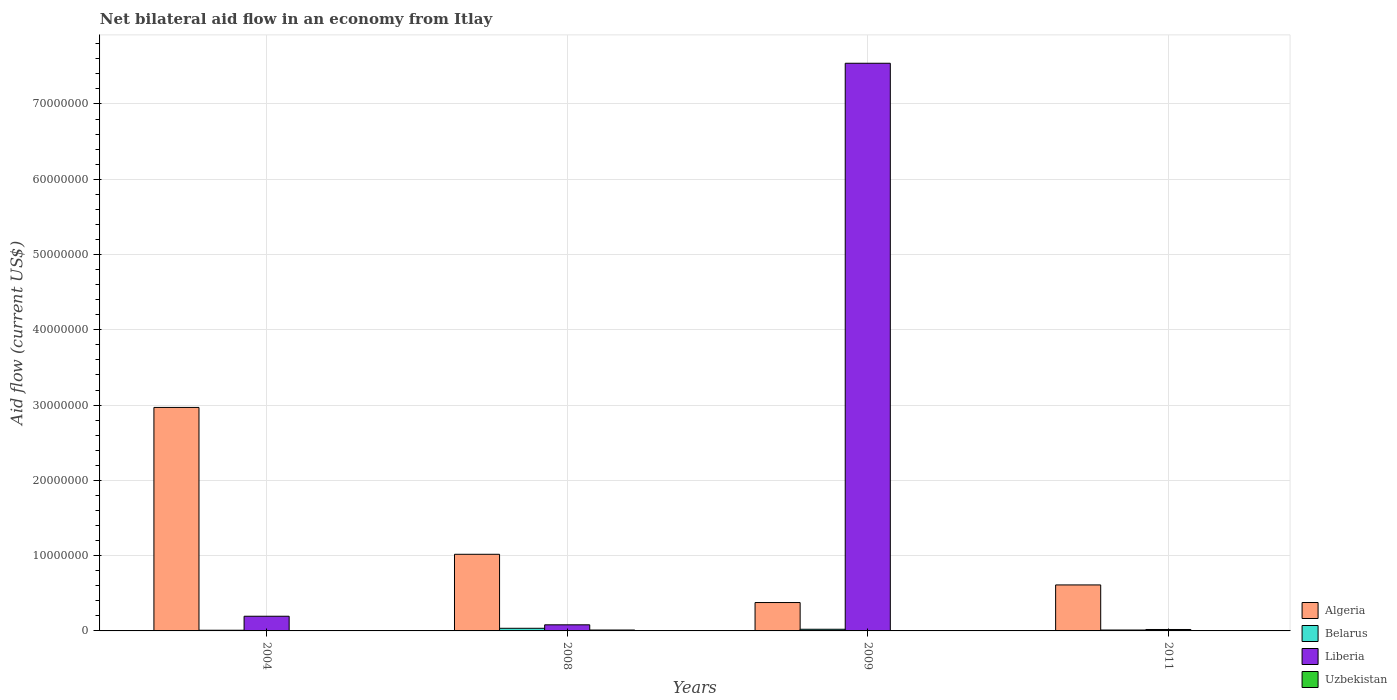How many different coloured bars are there?
Your response must be concise. 4. Are the number of bars per tick equal to the number of legend labels?
Ensure brevity in your answer.  Yes. How many bars are there on the 4th tick from the left?
Offer a very short reply. 4. How many bars are there on the 3rd tick from the right?
Offer a very short reply. 4. What is the label of the 1st group of bars from the left?
Your answer should be very brief. 2004. In how many cases, is the number of bars for a given year not equal to the number of legend labels?
Your response must be concise. 0. What is the net bilateral aid flow in Liberia in 2004?
Provide a short and direct response. 1.95e+06. Across all years, what is the maximum net bilateral aid flow in Algeria?
Your answer should be compact. 2.97e+07. Across all years, what is the minimum net bilateral aid flow in Belarus?
Give a very brief answer. 9.00e+04. What is the total net bilateral aid flow in Liberia in the graph?
Keep it short and to the point. 7.84e+07. What is the difference between the net bilateral aid flow in Liberia in 2004 and that in 2009?
Provide a short and direct response. -7.35e+07. What is the difference between the net bilateral aid flow in Algeria in 2009 and the net bilateral aid flow in Liberia in 2004?
Make the answer very short. 1.82e+06. What is the average net bilateral aid flow in Algeria per year?
Offer a very short reply. 1.24e+07. In the year 2008, what is the difference between the net bilateral aid flow in Algeria and net bilateral aid flow in Belarus?
Give a very brief answer. 9.83e+06. What is the ratio of the net bilateral aid flow in Uzbekistan in 2008 to that in 2009?
Provide a short and direct response. 4. Is the net bilateral aid flow in Liberia in 2009 less than that in 2011?
Ensure brevity in your answer.  No. Is the difference between the net bilateral aid flow in Algeria in 2008 and 2011 greater than the difference between the net bilateral aid flow in Belarus in 2008 and 2011?
Your answer should be compact. Yes. What is the difference between the highest and the second highest net bilateral aid flow in Liberia?
Offer a very short reply. 7.35e+07. What is the difference between the highest and the lowest net bilateral aid flow in Liberia?
Provide a succinct answer. 7.52e+07. In how many years, is the net bilateral aid flow in Uzbekistan greater than the average net bilateral aid flow in Uzbekistan taken over all years?
Your answer should be very brief. 1. What does the 4th bar from the left in 2011 represents?
Make the answer very short. Uzbekistan. What does the 4th bar from the right in 2009 represents?
Your response must be concise. Algeria. Is it the case that in every year, the sum of the net bilateral aid flow in Liberia and net bilateral aid flow in Belarus is greater than the net bilateral aid flow in Uzbekistan?
Offer a very short reply. Yes. How many bars are there?
Your answer should be compact. 16. Are all the bars in the graph horizontal?
Give a very brief answer. No. How many years are there in the graph?
Your answer should be compact. 4. Are the values on the major ticks of Y-axis written in scientific E-notation?
Provide a short and direct response. No. Where does the legend appear in the graph?
Offer a terse response. Bottom right. How many legend labels are there?
Give a very brief answer. 4. How are the legend labels stacked?
Your answer should be compact. Vertical. What is the title of the graph?
Ensure brevity in your answer.  Net bilateral aid flow in an economy from Itlay. What is the label or title of the X-axis?
Ensure brevity in your answer.  Years. What is the label or title of the Y-axis?
Offer a very short reply. Aid flow (current US$). What is the Aid flow (current US$) of Algeria in 2004?
Keep it short and to the point. 2.97e+07. What is the Aid flow (current US$) in Liberia in 2004?
Your answer should be compact. 1.95e+06. What is the Aid flow (current US$) of Algeria in 2008?
Keep it short and to the point. 1.02e+07. What is the Aid flow (current US$) in Belarus in 2008?
Keep it short and to the point. 3.50e+05. What is the Aid flow (current US$) in Liberia in 2008?
Your response must be concise. 8.10e+05. What is the Aid flow (current US$) in Algeria in 2009?
Make the answer very short. 3.77e+06. What is the Aid flow (current US$) of Belarus in 2009?
Your answer should be very brief. 2.20e+05. What is the Aid flow (current US$) of Liberia in 2009?
Ensure brevity in your answer.  7.54e+07. What is the Aid flow (current US$) of Uzbekistan in 2009?
Make the answer very short. 3.00e+04. What is the Aid flow (current US$) in Algeria in 2011?
Your answer should be compact. 6.11e+06. What is the Aid flow (current US$) in Liberia in 2011?
Offer a terse response. 1.90e+05. What is the Aid flow (current US$) of Uzbekistan in 2011?
Offer a very short reply. 3.00e+04. Across all years, what is the maximum Aid flow (current US$) in Algeria?
Provide a short and direct response. 2.97e+07. Across all years, what is the maximum Aid flow (current US$) in Belarus?
Your response must be concise. 3.50e+05. Across all years, what is the maximum Aid flow (current US$) in Liberia?
Give a very brief answer. 7.54e+07. Across all years, what is the minimum Aid flow (current US$) of Algeria?
Provide a short and direct response. 3.77e+06. Across all years, what is the minimum Aid flow (current US$) in Liberia?
Your response must be concise. 1.90e+05. Across all years, what is the minimum Aid flow (current US$) in Uzbekistan?
Offer a very short reply. 10000. What is the total Aid flow (current US$) of Algeria in the graph?
Keep it short and to the point. 4.98e+07. What is the total Aid flow (current US$) of Belarus in the graph?
Offer a terse response. 7.80e+05. What is the total Aid flow (current US$) of Liberia in the graph?
Ensure brevity in your answer.  7.84e+07. What is the difference between the Aid flow (current US$) of Algeria in 2004 and that in 2008?
Provide a succinct answer. 1.95e+07. What is the difference between the Aid flow (current US$) in Belarus in 2004 and that in 2008?
Give a very brief answer. -2.60e+05. What is the difference between the Aid flow (current US$) of Liberia in 2004 and that in 2008?
Offer a terse response. 1.14e+06. What is the difference between the Aid flow (current US$) of Uzbekistan in 2004 and that in 2008?
Offer a very short reply. -1.10e+05. What is the difference between the Aid flow (current US$) of Algeria in 2004 and that in 2009?
Offer a very short reply. 2.59e+07. What is the difference between the Aid flow (current US$) in Liberia in 2004 and that in 2009?
Your response must be concise. -7.35e+07. What is the difference between the Aid flow (current US$) in Uzbekistan in 2004 and that in 2009?
Your answer should be compact. -2.00e+04. What is the difference between the Aid flow (current US$) in Algeria in 2004 and that in 2011?
Your answer should be very brief. 2.36e+07. What is the difference between the Aid flow (current US$) in Belarus in 2004 and that in 2011?
Keep it short and to the point. -3.00e+04. What is the difference between the Aid flow (current US$) in Liberia in 2004 and that in 2011?
Provide a short and direct response. 1.76e+06. What is the difference between the Aid flow (current US$) of Uzbekistan in 2004 and that in 2011?
Provide a short and direct response. -2.00e+04. What is the difference between the Aid flow (current US$) of Algeria in 2008 and that in 2009?
Offer a terse response. 6.41e+06. What is the difference between the Aid flow (current US$) of Liberia in 2008 and that in 2009?
Offer a very short reply. -7.46e+07. What is the difference between the Aid flow (current US$) of Uzbekistan in 2008 and that in 2009?
Ensure brevity in your answer.  9.00e+04. What is the difference between the Aid flow (current US$) of Algeria in 2008 and that in 2011?
Give a very brief answer. 4.07e+06. What is the difference between the Aid flow (current US$) in Belarus in 2008 and that in 2011?
Your answer should be very brief. 2.30e+05. What is the difference between the Aid flow (current US$) in Liberia in 2008 and that in 2011?
Offer a very short reply. 6.20e+05. What is the difference between the Aid flow (current US$) of Algeria in 2009 and that in 2011?
Provide a short and direct response. -2.34e+06. What is the difference between the Aid flow (current US$) in Belarus in 2009 and that in 2011?
Ensure brevity in your answer.  1.00e+05. What is the difference between the Aid flow (current US$) of Liberia in 2009 and that in 2011?
Ensure brevity in your answer.  7.52e+07. What is the difference between the Aid flow (current US$) of Algeria in 2004 and the Aid flow (current US$) of Belarus in 2008?
Your answer should be compact. 2.93e+07. What is the difference between the Aid flow (current US$) of Algeria in 2004 and the Aid flow (current US$) of Liberia in 2008?
Keep it short and to the point. 2.89e+07. What is the difference between the Aid flow (current US$) in Algeria in 2004 and the Aid flow (current US$) in Uzbekistan in 2008?
Your answer should be very brief. 2.96e+07. What is the difference between the Aid flow (current US$) in Belarus in 2004 and the Aid flow (current US$) in Liberia in 2008?
Make the answer very short. -7.20e+05. What is the difference between the Aid flow (current US$) of Liberia in 2004 and the Aid flow (current US$) of Uzbekistan in 2008?
Ensure brevity in your answer.  1.83e+06. What is the difference between the Aid flow (current US$) of Algeria in 2004 and the Aid flow (current US$) of Belarus in 2009?
Keep it short and to the point. 2.95e+07. What is the difference between the Aid flow (current US$) of Algeria in 2004 and the Aid flow (current US$) of Liberia in 2009?
Provide a short and direct response. -4.57e+07. What is the difference between the Aid flow (current US$) of Algeria in 2004 and the Aid flow (current US$) of Uzbekistan in 2009?
Your response must be concise. 2.97e+07. What is the difference between the Aid flow (current US$) of Belarus in 2004 and the Aid flow (current US$) of Liberia in 2009?
Ensure brevity in your answer.  -7.53e+07. What is the difference between the Aid flow (current US$) in Liberia in 2004 and the Aid flow (current US$) in Uzbekistan in 2009?
Make the answer very short. 1.92e+06. What is the difference between the Aid flow (current US$) of Algeria in 2004 and the Aid flow (current US$) of Belarus in 2011?
Provide a succinct answer. 2.96e+07. What is the difference between the Aid flow (current US$) of Algeria in 2004 and the Aid flow (current US$) of Liberia in 2011?
Give a very brief answer. 2.95e+07. What is the difference between the Aid flow (current US$) in Algeria in 2004 and the Aid flow (current US$) in Uzbekistan in 2011?
Your answer should be compact. 2.97e+07. What is the difference between the Aid flow (current US$) of Belarus in 2004 and the Aid flow (current US$) of Liberia in 2011?
Provide a succinct answer. -1.00e+05. What is the difference between the Aid flow (current US$) in Liberia in 2004 and the Aid flow (current US$) in Uzbekistan in 2011?
Offer a terse response. 1.92e+06. What is the difference between the Aid flow (current US$) of Algeria in 2008 and the Aid flow (current US$) of Belarus in 2009?
Provide a succinct answer. 9.96e+06. What is the difference between the Aid flow (current US$) of Algeria in 2008 and the Aid flow (current US$) of Liberia in 2009?
Provide a succinct answer. -6.52e+07. What is the difference between the Aid flow (current US$) in Algeria in 2008 and the Aid flow (current US$) in Uzbekistan in 2009?
Provide a succinct answer. 1.02e+07. What is the difference between the Aid flow (current US$) of Belarus in 2008 and the Aid flow (current US$) of Liberia in 2009?
Ensure brevity in your answer.  -7.51e+07. What is the difference between the Aid flow (current US$) of Belarus in 2008 and the Aid flow (current US$) of Uzbekistan in 2009?
Give a very brief answer. 3.20e+05. What is the difference between the Aid flow (current US$) of Liberia in 2008 and the Aid flow (current US$) of Uzbekistan in 2009?
Your answer should be very brief. 7.80e+05. What is the difference between the Aid flow (current US$) in Algeria in 2008 and the Aid flow (current US$) in Belarus in 2011?
Your answer should be very brief. 1.01e+07. What is the difference between the Aid flow (current US$) in Algeria in 2008 and the Aid flow (current US$) in Liberia in 2011?
Keep it short and to the point. 9.99e+06. What is the difference between the Aid flow (current US$) in Algeria in 2008 and the Aid flow (current US$) in Uzbekistan in 2011?
Give a very brief answer. 1.02e+07. What is the difference between the Aid flow (current US$) in Belarus in 2008 and the Aid flow (current US$) in Liberia in 2011?
Keep it short and to the point. 1.60e+05. What is the difference between the Aid flow (current US$) of Belarus in 2008 and the Aid flow (current US$) of Uzbekistan in 2011?
Provide a succinct answer. 3.20e+05. What is the difference between the Aid flow (current US$) in Liberia in 2008 and the Aid flow (current US$) in Uzbekistan in 2011?
Your answer should be very brief. 7.80e+05. What is the difference between the Aid flow (current US$) in Algeria in 2009 and the Aid flow (current US$) in Belarus in 2011?
Your answer should be very brief. 3.65e+06. What is the difference between the Aid flow (current US$) in Algeria in 2009 and the Aid flow (current US$) in Liberia in 2011?
Your response must be concise. 3.58e+06. What is the difference between the Aid flow (current US$) of Algeria in 2009 and the Aid flow (current US$) of Uzbekistan in 2011?
Make the answer very short. 3.74e+06. What is the difference between the Aid flow (current US$) in Belarus in 2009 and the Aid flow (current US$) in Liberia in 2011?
Provide a short and direct response. 3.00e+04. What is the difference between the Aid flow (current US$) of Liberia in 2009 and the Aid flow (current US$) of Uzbekistan in 2011?
Provide a succinct answer. 7.54e+07. What is the average Aid flow (current US$) of Algeria per year?
Your response must be concise. 1.24e+07. What is the average Aid flow (current US$) in Belarus per year?
Offer a terse response. 1.95e+05. What is the average Aid flow (current US$) of Liberia per year?
Give a very brief answer. 1.96e+07. What is the average Aid flow (current US$) in Uzbekistan per year?
Offer a very short reply. 4.75e+04. In the year 2004, what is the difference between the Aid flow (current US$) in Algeria and Aid flow (current US$) in Belarus?
Ensure brevity in your answer.  2.96e+07. In the year 2004, what is the difference between the Aid flow (current US$) in Algeria and Aid flow (current US$) in Liberia?
Provide a succinct answer. 2.77e+07. In the year 2004, what is the difference between the Aid flow (current US$) in Algeria and Aid flow (current US$) in Uzbekistan?
Your response must be concise. 2.97e+07. In the year 2004, what is the difference between the Aid flow (current US$) in Belarus and Aid flow (current US$) in Liberia?
Your response must be concise. -1.86e+06. In the year 2004, what is the difference between the Aid flow (current US$) of Belarus and Aid flow (current US$) of Uzbekistan?
Keep it short and to the point. 8.00e+04. In the year 2004, what is the difference between the Aid flow (current US$) in Liberia and Aid flow (current US$) in Uzbekistan?
Ensure brevity in your answer.  1.94e+06. In the year 2008, what is the difference between the Aid flow (current US$) of Algeria and Aid flow (current US$) of Belarus?
Offer a very short reply. 9.83e+06. In the year 2008, what is the difference between the Aid flow (current US$) of Algeria and Aid flow (current US$) of Liberia?
Provide a succinct answer. 9.37e+06. In the year 2008, what is the difference between the Aid flow (current US$) of Algeria and Aid flow (current US$) of Uzbekistan?
Your answer should be compact. 1.01e+07. In the year 2008, what is the difference between the Aid flow (current US$) in Belarus and Aid flow (current US$) in Liberia?
Ensure brevity in your answer.  -4.60e+05. In the year 2008, what is the difference between the Aid flow (current US$) in Belarus and Aid flow (current US$) in Uzbekistan?
Your answer should be compact. 2.30e+05. In the year 2008, what is the difference between the Aid flow (current US$) of Liberia and Aid flow (current US$) of Uzbekistan?
Provide a short and direct response. 6.90e+05. In the year 2009, what is the difference between the Aid flow (current US$) in Algeria and Aid flow (current US$) in Belarus?
Your answer should be very brief. 3.55e+06. In the year 2009, what is the difference between the Aid flow (current US$) of Algeria and Aid flow (current US$) of Liberia?
Give a very brief answer. -7.16e+07. In the year 2009, what is the difference between the Aid flow (current US$) in Algeria and Aid flow (current US$) in Uzbekistan?
Your response must be concise. 3.74e+06. In the year 2009, what is the difference between the Aid flow (current US$) in Belarus and Aid flow (current US$) in Liberia?
Give a very brief answer. -7.52e+07. In the year 2009, what is the difference between the Aid flow (current US$) in Liberia and Aid flow (current US$) in Uzbekistan?
Provide a succinct answer. 7.54e+07. In the year 2011, what is the difference between the Aid flow (current US$) of Algeria and Aid flow (current US$) of Belarus?
Make the answer very short. 5.99e+06. In the year 2011, what is the difference between the Aid flow (current US$) of Algeria and Aid flow (current US$) of Liberia?
Your answer should be compact. 5.92e+06. In the year 2011, what is the difference between the Aid flow (current US$) of Algeria and Aid flow (current US$) of Uzbekistan?
Keep it short and to the point. 6.08e+06. In the year 2011, what is the difference between the Aid flow (current US$) of Belarus and Aid flow (current US$) of Uzbekistan?
Keep it short and to the point. 9.00e+04. In the year 2011, what is the difference between the Aid flow (current US$) in Liberia and Aid flow (current US$) in Uzbekistan?
Your answer should be very brief. 1.60e+05. What is the ratio of the Aid flow (current US$) of Algeria in 2004 to that in 2008?
Give a very brief answer. 2.92. What is the ratio of the Aid flow (current US$) of Belarus in 2004 to that in 2008?
Ensure brevity in your answer.  0.26. What is the ratio of the Aid flow (current US$) of Liberia in 2004 to that in 2008?
Provide a short and direct response. 2.41. What is the ratio of the Aid flow (current US$) in Uzbekistan in 2004 to that in 2008?
Offer a very short reply. 0.08. What is the ratio of the Aid flow (current US$) of Algeria in 2004 to that in 2009?
Your answer should be compact. 7.88. What is the ratio of the Aid flow (current US$) in Belarus in 2004 to that in 2009?
Provide a short and direct response. 0.41. What is the ratio of the Aid flow (current US$) in Liberia in 2004 to that in 2009?
Your answer should be compact. 0.03. What is the ratio of the Aid flow (current US$) in Algeria in 2004 to that in 2011?
Give a very brief answer. 4.86. What is the ratio of the Aid flow (current US$) of Belarus in 2004 to that in 2011?
Your answer should be compact. 0.75. What is the ratio of the Aid flow (current US$) of Liberia in 2004 to that in 2011?
Your response must be concise. 10.26. What is the ratio of the Aid flow (current US$) of Algeria in 2008 to that in 2009?
Keep it short and to the point. 2.7. What is the ratio of the Aid flow (current US$) of Belarus in 2008 to that in 2009?
Provide a succinct answer. 1.59. What is the ratio of the Aid flow (current US$) in Liberia in 2008 to that in 2009?
Your response must be concise. 0.01. What is the ratio of the Aid flow (current US$) of Algeria in 2008 to that in 2011?
Offer a terse response. 1.67. What is the ratio of the Aid flow (current US$) of Belarus in 2008 to that in 2011?
Provide a succinct answer. 2.92. What is the ratio of the Aid flow (current US$) of Liberia in 2008 to that in 2011?
Your answer should be compact. 4.26. What is the ratio of the Aid flow (current US$) in Algeria in 2009 to that in 2011?
Give a very brief answer. 0.62. What is the ratio of the Aid flow (current US$) in Belarus in 2009 to that in 2011?
Provide a succinct answer. 1.83. What is the ratio of the Aid flow (current US$) of Liberia in 2009 to that in 2011?
Offer a terse response. 396.89. What is the difference between the highest and the second highest Aid flow (current US$) in Algeria?
Keep it short and to the point. 1.95e+07. What is the difference between the highest and the second highest Aid flow (current US$) in Belarus?
Offer a terse response. 1.30e+05. What is the difference between the highest and the second highest Aid flow (current US$) in Liberia?
Ensure brevity in your answer.  7.35e+07. What is the difference between the highest and the lowest Aid flow (current US$) in Algeria?
Your answer should be very brief. 2.59e+07. What is the difference between the highest and the lowest Aid flow (current US$) of Belarus?
Offer a terse response. 2.60e+05. What is the difference between the highest and the lowest Aid flow (current US$) of Liberia?
Your response must be concise. 7.52e+07. What is the difference between the highest and the lowest Aid flow (current US$) of Uzbekistan?
Your response must be concise. 1.10e+05. 